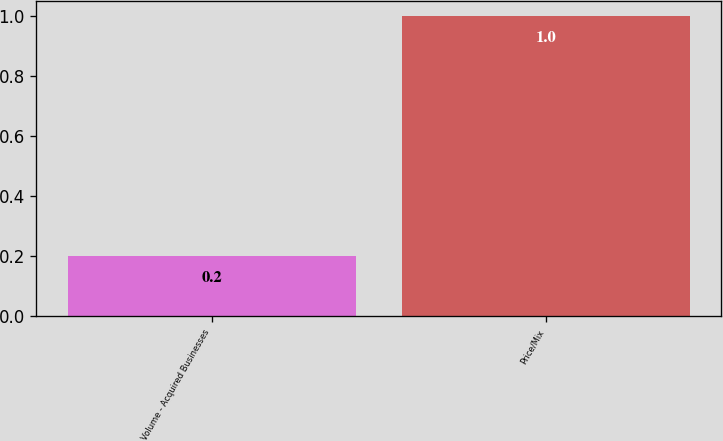Convert chart. <chart><loc_0><loc_0><loc_500><loc_500><bar_chart><fcel>Volume - Acquired Businesses<fcel>Price/Mix<nl><fcel>0.2<fcel>1<nl></chart> 